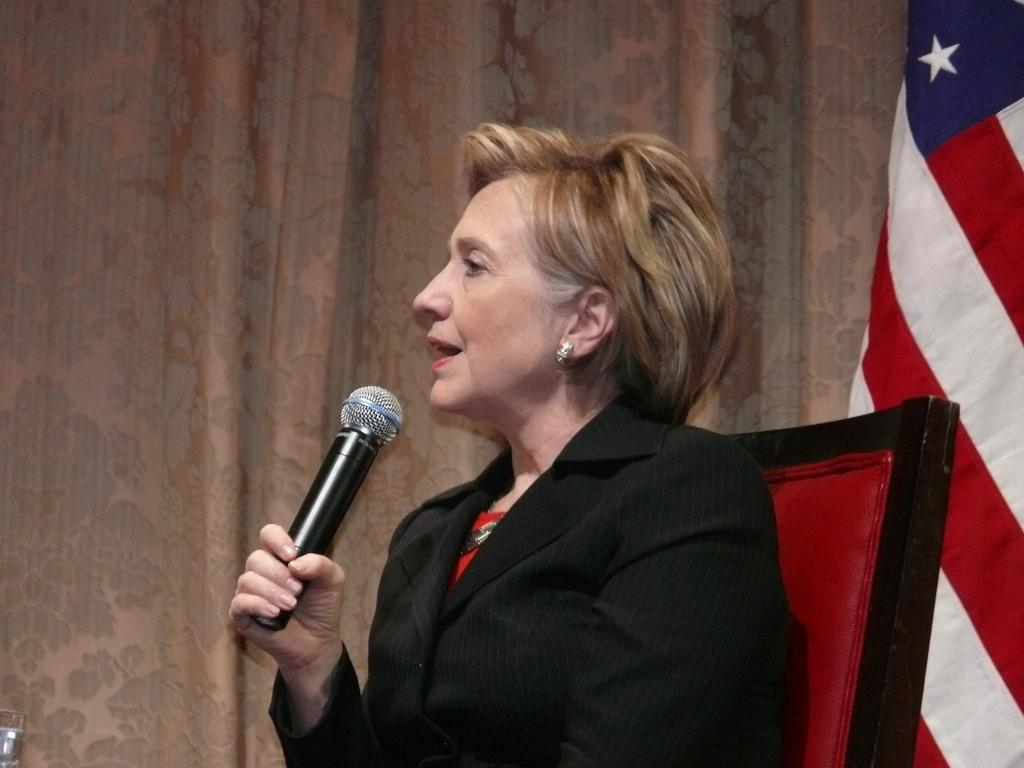What is the person in the image doing? The person is sitting on a chair. What is the person wearing? The person is wearing a black suit. What object is the person holding? The person is holding a microphone in her hand. What can be seen at the right side of the image? There is a flag at the right side of the image. What is visible in the background of the image? There are curtains visible in the background. What type of weather can be seen in the image? There is no indication of weather in the image, as it is an indoor setting with curtains visible in the background. 